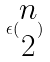<formula> <loc_0><loc_0><loc_500><loc_500>\epsilon ( \begin{matrix} n \\ 2 \end{matrix} )</formula> 